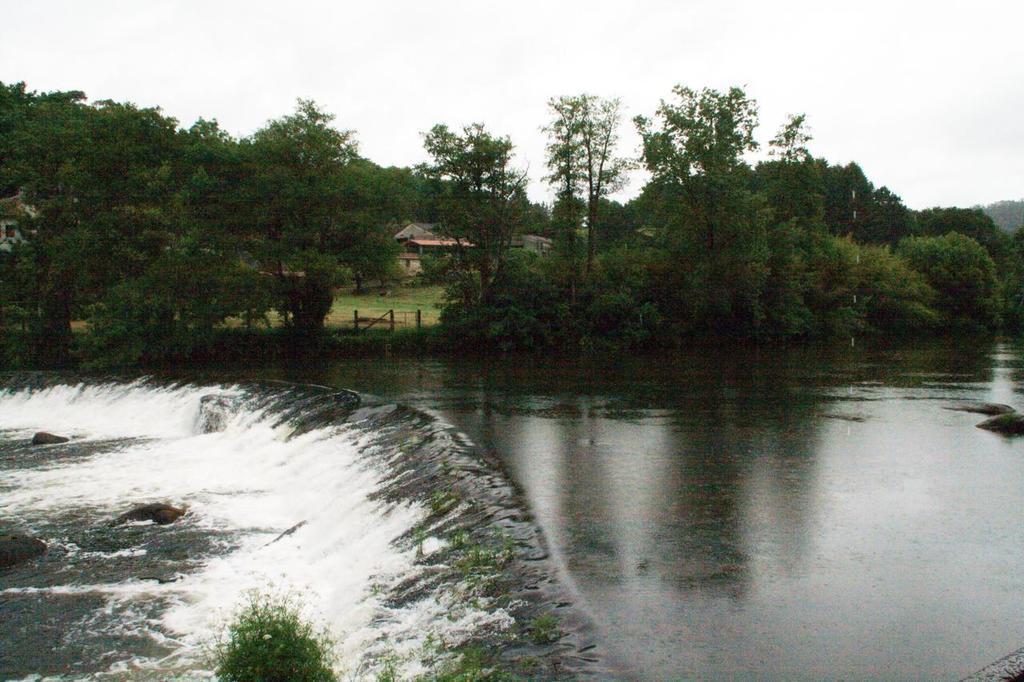Could you give a brief overview of what you see in this image? In this image in the center there is water. In the background there are trees and there's grass on the ground and there is a house. 